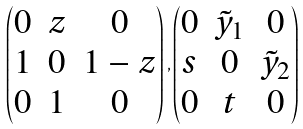<formula> <loc_0><loc_0><loc_500><loc_500>\begin{pmatrix} 0 & z & 0 \\ 1 & 0 & 1 - z \\ 0 & 1 & 0 \end{pmatrix} , \begin{pmatrix} 0 & \tilde { y } _ { 1 } & 0 \\ s & 0 & \tilde { y } _ { 2 } \\ 0 & t & 0 \end{pmatrix}</formula> 